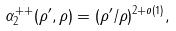Convert formula to latex. <formula><loc_0><loc_0><loc_500><loc_500>\alpha _ { 2 } ^ { + + } ( \rho ^ { \prime } , \rho ) = ( \rho ^ { \prime } / \rho ) ^ { 2 + o ( 1 ) } ,</formula> 